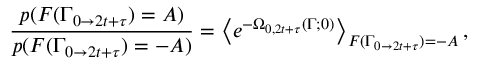Convert formula to latex. <formula><loc_0><loc_0><loc_500><loc_500>\frac { p ( F ( \Gamma _ { 0 \rightarrow 2 t + \tau } ) = A ) } { p ( F ( \Gamma _ { 0 \rightarrow 2 t + \tau } ) = - A ) } = \left < e ^ { - \Omega _ { 0 , 2 t + \tau } ( \Gamma ; 0 ) } \right > _ { F ( \Gamma _ { 0 \rightarrow 2 t + \tau } ) = - A } ,</formula> 